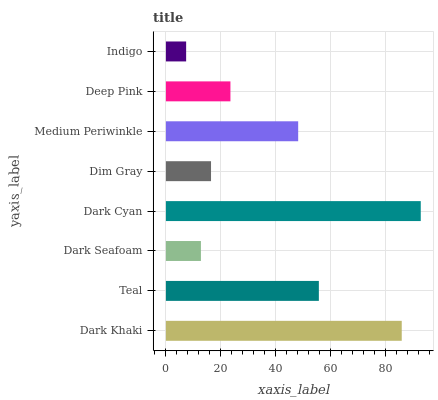Is Indigo the minimum?
Answer yes or no. Yes. Is Dark Cyan the maximum?
Answer yes or no. Yes. Is Teal the minimum?
Answer yes or no. No. Is Teal the maximum?
Answer yes or no. No. Is Dark Khaki greater than Teal?
Answer yes or no. Yes. Is Teal less than Dark Khaki?
Answer yes or no. Yes. Is Teal greater than Dark Khaki?
Answer yes or no. No. Is Dark Khaki less than Teal?
Answer yes or no. No. Is Medium Periwinkle the high median?
Answer yes or no. Yes. Is Deep Pink the low median?
Answer yes or no. Yes. Is Dark Khaki the high median?
Answer yes or no. No. Is Dim Gray the low median?
Answer yes or no. No. 